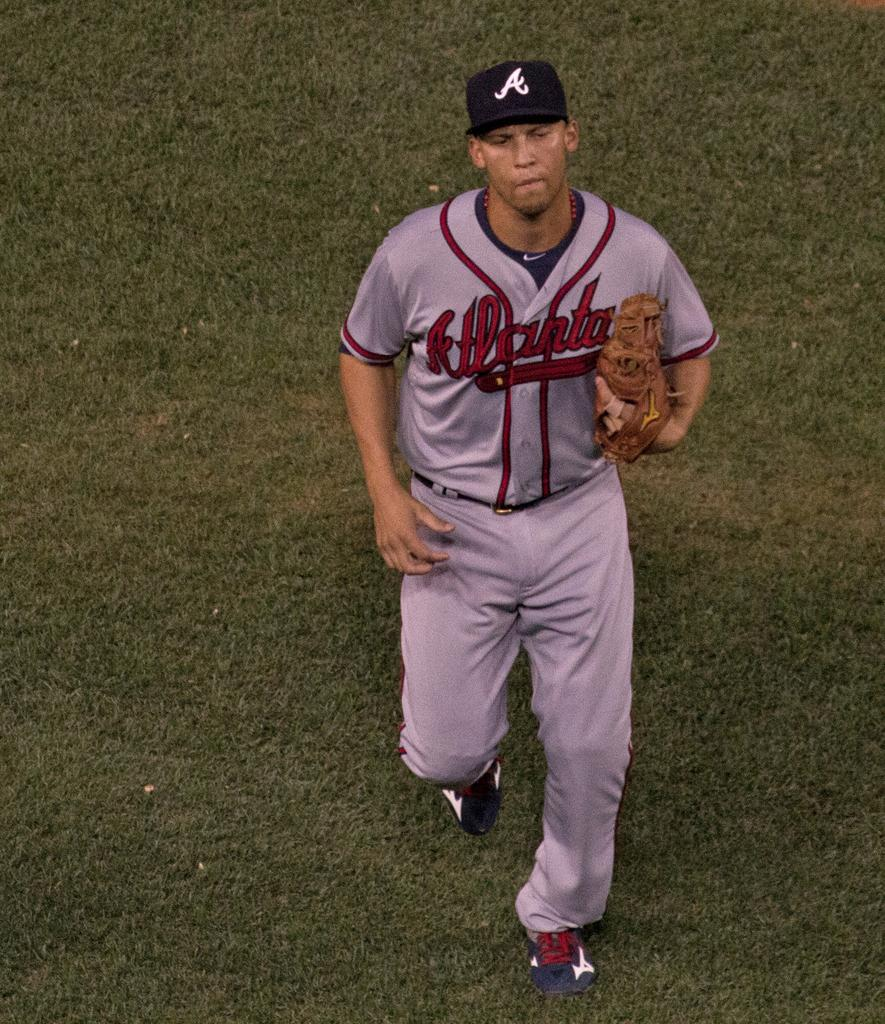<image>
Render a clear and concise summary of the photo. an atlanta braves player running on the grass 